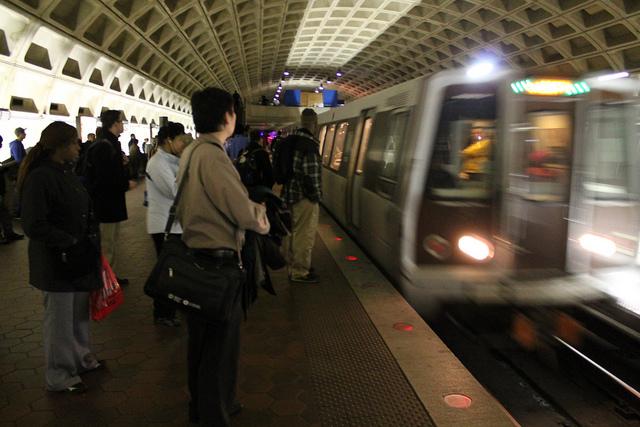What are they waiting for?
Quick response, please. Train. What color of bag is the lady wearing?
Write a very short answer. Black. Is the train moving?
Give a very brief answer. Yes. 